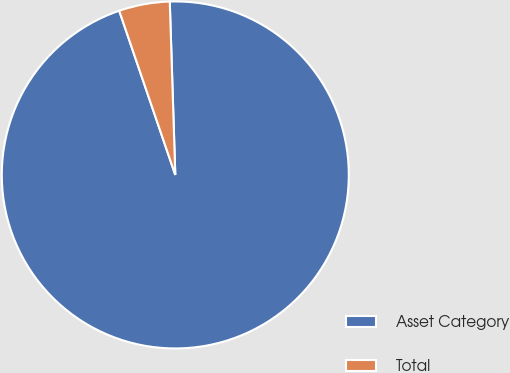<chart> <loc_0><loc_0><loc_500><loc_500><pie_chart><fcel>Asset Category<fcel>Total<nl><fcel>95.27%<fcel>4.73%<nl></chart> 